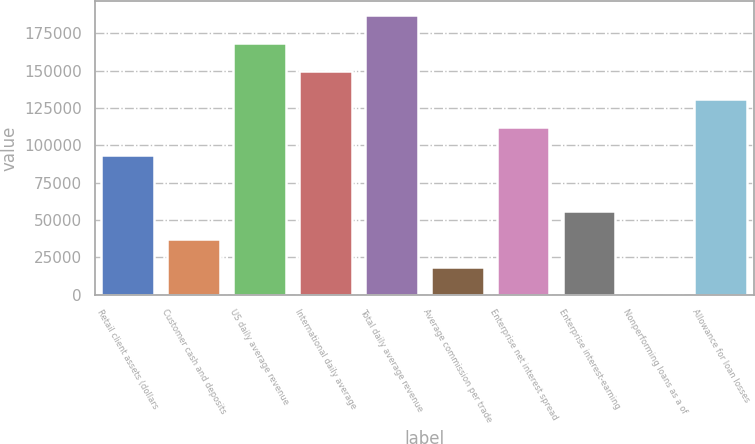Convert chart to OTSL. <chart><loc_0><loc_0><loc_500><loc_500><bar_chart><fcel>Retail client assets (dollars<fcel>Customer cash and deposits<fcel>US daily average revenue<fcel>International daily average<fcel>Total daily average revenue<fcel>Average commission per trade<fcel>Enterprise net interest spread<fcel>Enterprise interest-earning<fcel>Nonperforming loans as a of<fcel>Allowance for loan losses<nl><fcel>93511.7<fcel>37405.5<fcel>168320<fcel>149618<fcel>187022<fcel>18703.4<fcel>112214<fcel>56107.6<fcel>1.37<fcel>130916<nl></chart> 